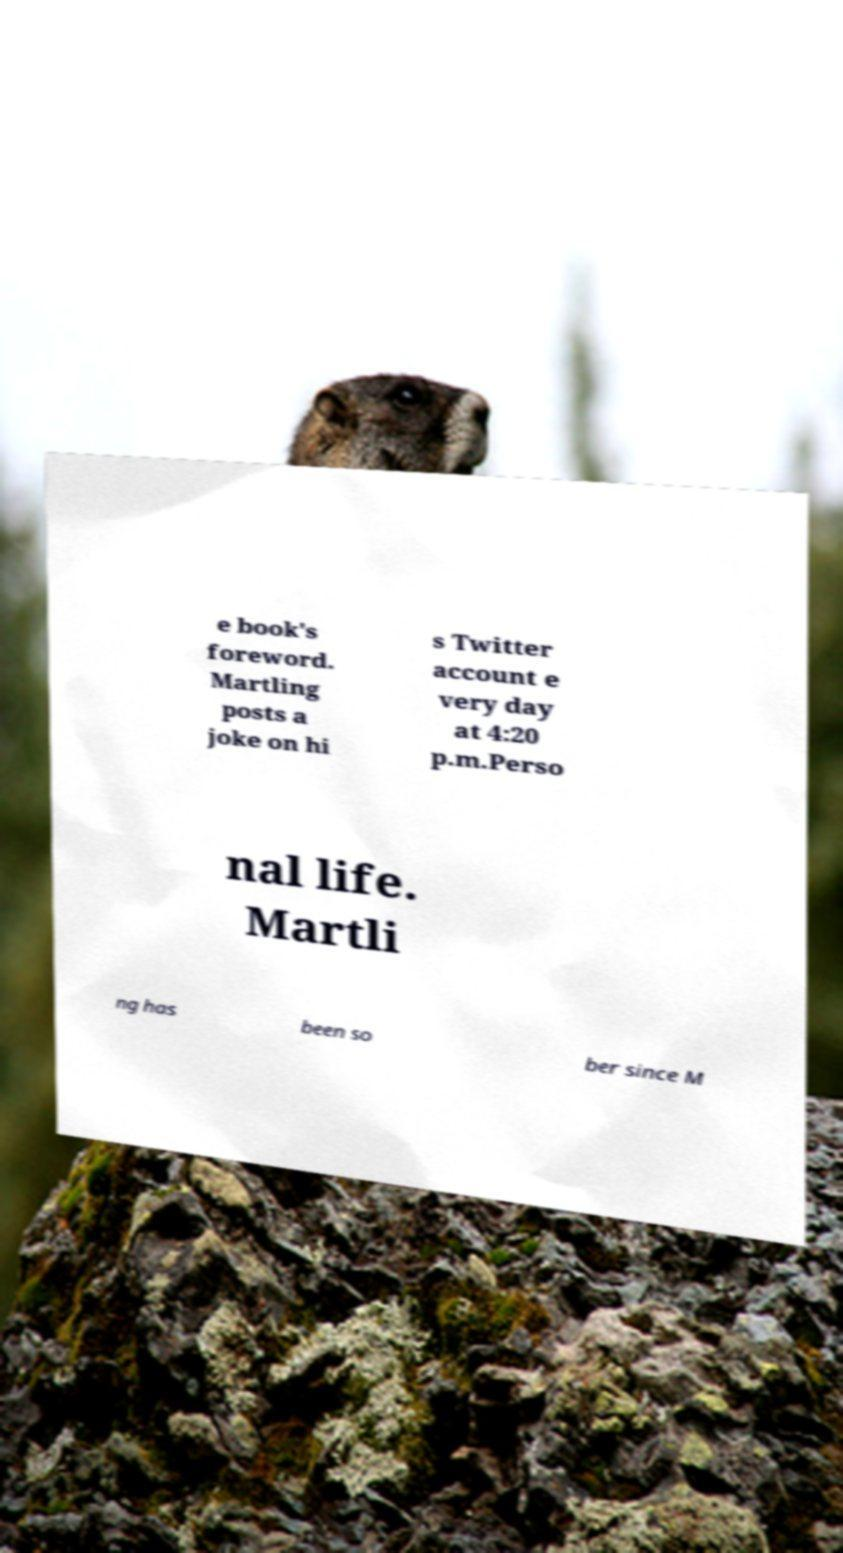For documentation purposes, I need the text within this image transcribed. Could you provide that? e book's foreword. Martling posts a joke on hi s Twitter account e very day at 4:20 p.m.Perso nal life. Martli ng has been so ber since M 